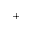Convert formula to latex. <formula><loc_0><loc_0><loc_500><loc_500>^ { + }</formula> 